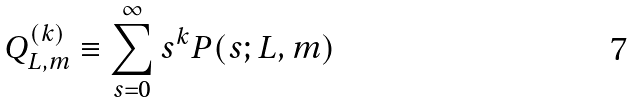Convert formula to latex. <formula><loc_0><loc_0><loc_500><loc_500>Q ^ { ( k ) } _ { L , m } \equiv \sum ^ { \infty } _ { s = 0 } s ^ { k } P ( s ; L , m )</formula> 